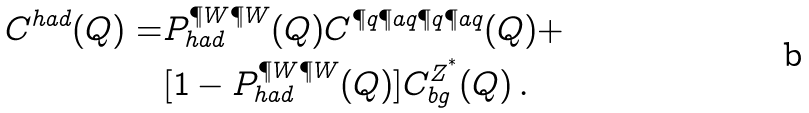<formula> <loc_0><loc_0><loc_500><loc_500>C ^ { h a d } ( Q ) = & P ^ { \P W \P W } _ { h a d } ( Q ) C ^ { \P q \P a q \P q \P a q } ( Q ) + \\ & [ 1 - P ^ { \P W \P W } _ { h a d } ( Q ) ] C _ { b g } ^ { Z ^ { ^ { * } } } ( Q ) \, .</formula> 